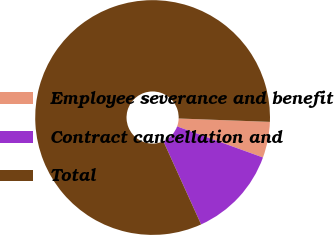Convert chart to OTSL. <chart><loc_0><loc_0><loc_500><loc_500><pie_chart><fcel>Employee severance and benefit<fcel>Contract cancellation and<fcel>Total<nl><fcel>4.94%<fcel>12.69%<fcel>82.37%<nl></chart> 